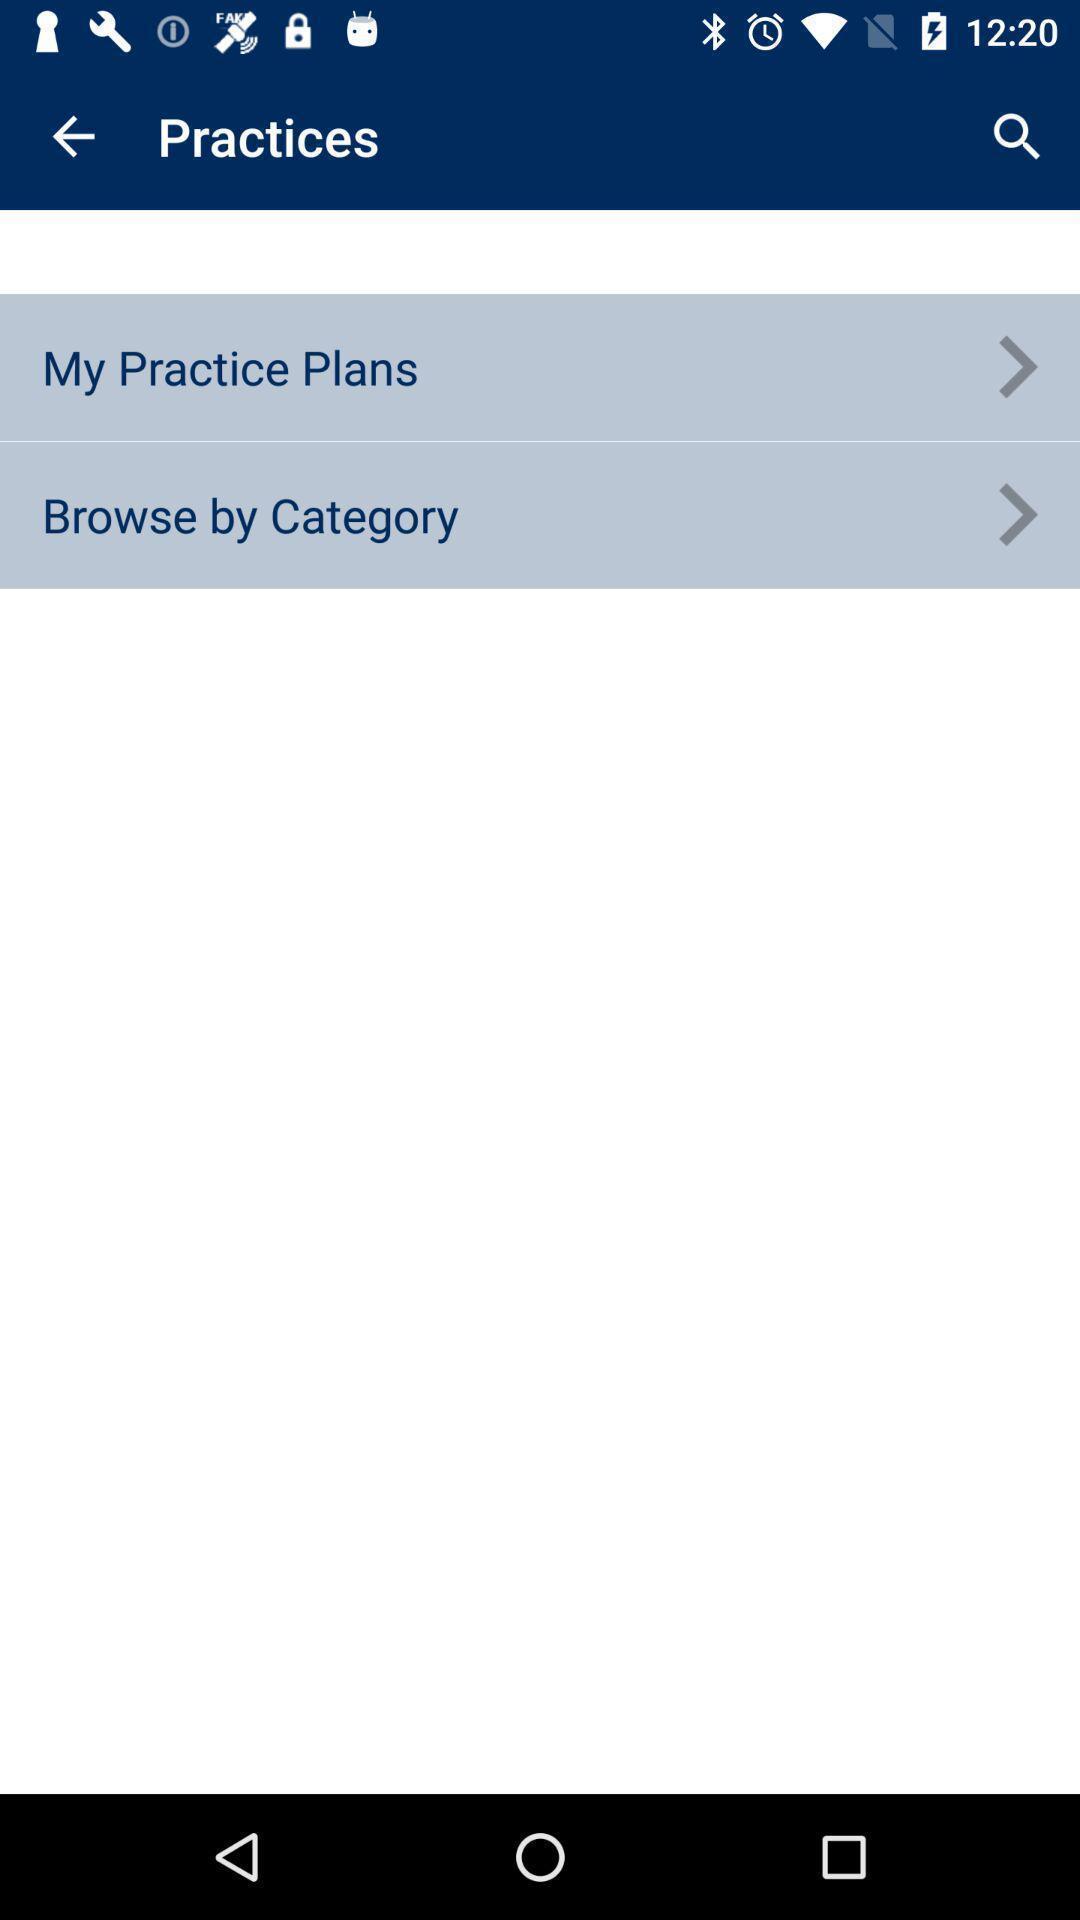Summarize the information in this screenshot. Sport app displaying practice plans and category options. 